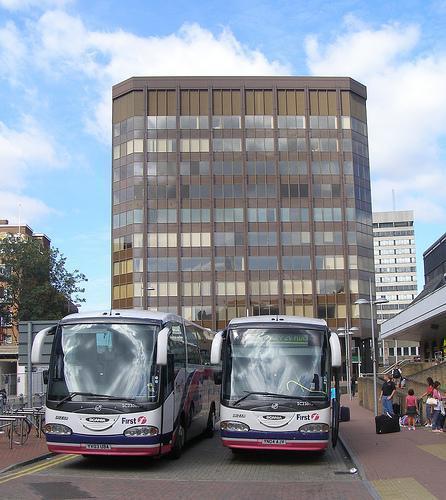How many buses are there waiting?
Give a very brief answer. 2. 